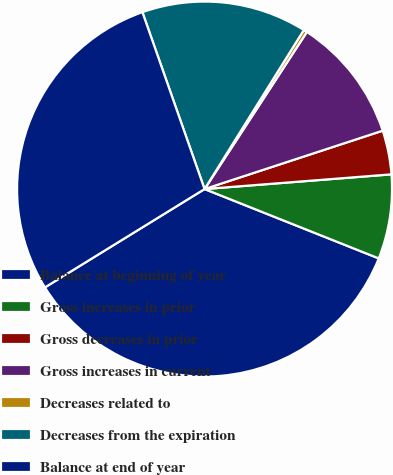Convert chart. <chart><loc_0><loc_0><loc_500><loc_500><pie_chart><fcel>Balance at beginning of year<fcel>Gross increases in prior<fcel>Gross decreases in prior<fcel>Gross increases in current<fcel>Decreases related to<fcel>Decreases from the expiration<fcel>Balance at end of year<nl><fcel>35.18%<fcel>7.28%<fcel>3.79%<fcel>10.77%<fcel>0.31%<fcel>14.26%<fcel>28.41%<nl></chart> 